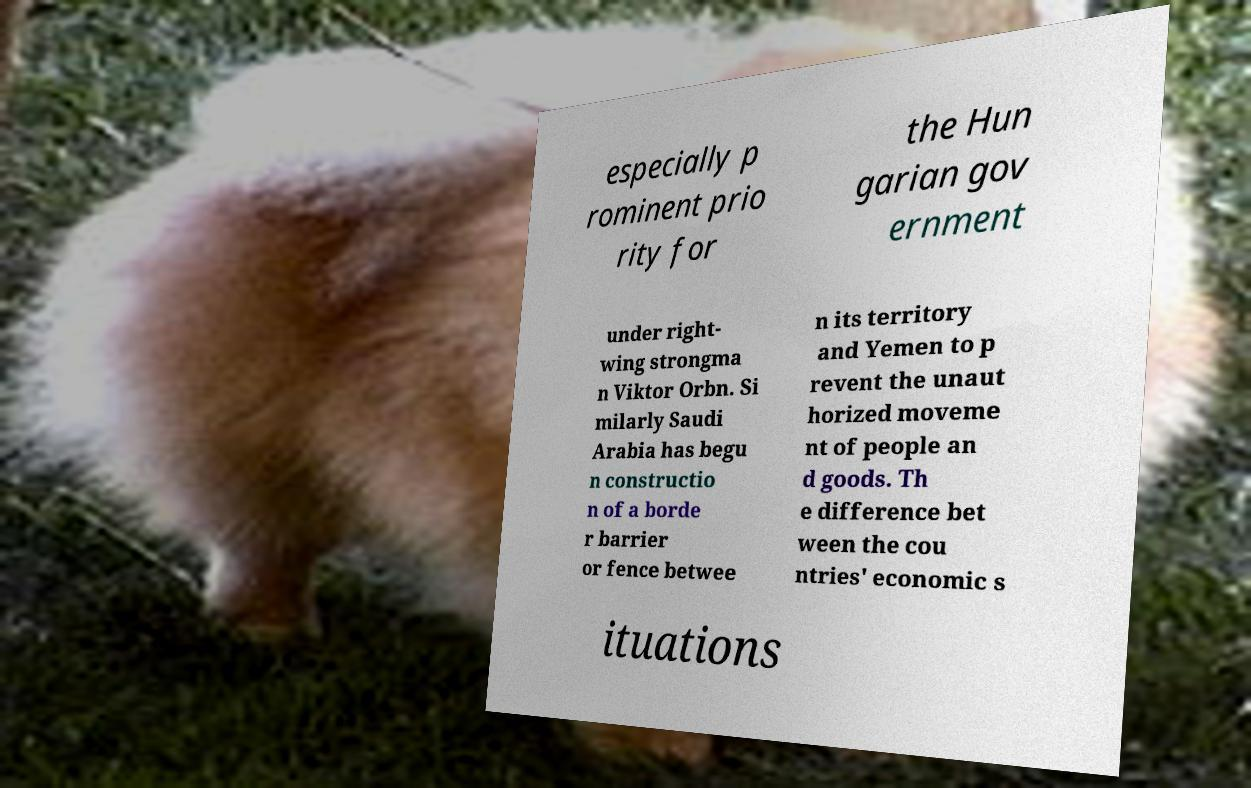Please identify and transcribe the text found in this image. especially p rominent prio rity for the Hun garian gov ernment under right- wing strongma n Viktor Orbn. Si milarly Saudi Arabia has begu n constructio n of a borde r barrier or fence betwee n its territory and Yemen to p revent the unaut horized moveme nt of people an d goods. Th e difference bet ween the cou ntries' economic s ituations 